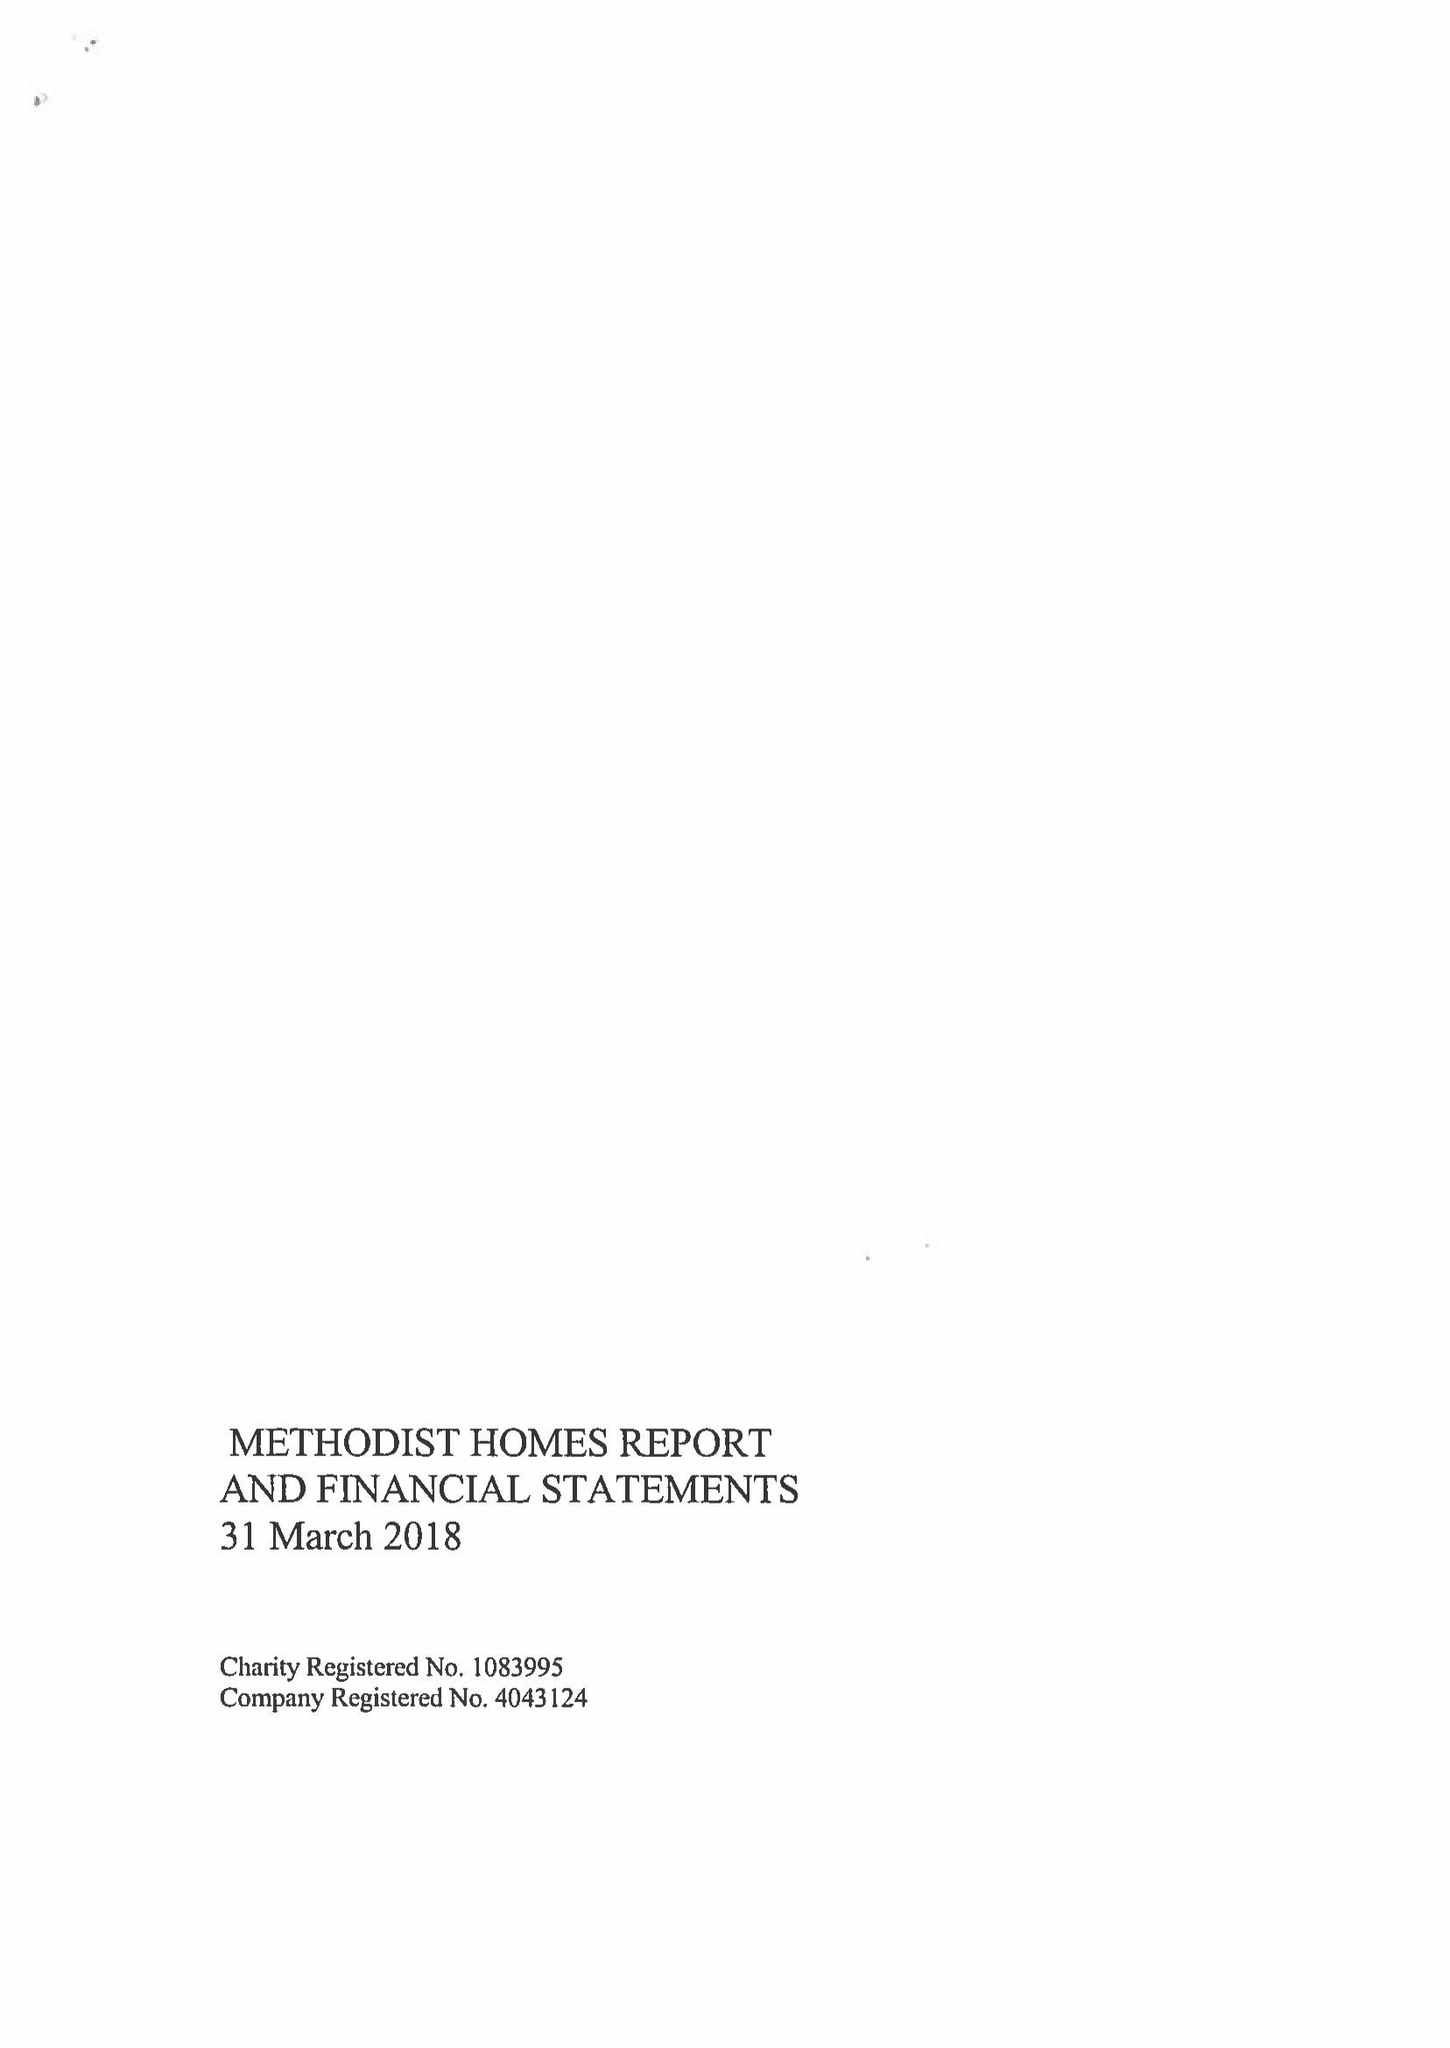What is the value for the spending_annually_in_british_pounds?
Answer the question using a single word or phrase. 213469000.00 